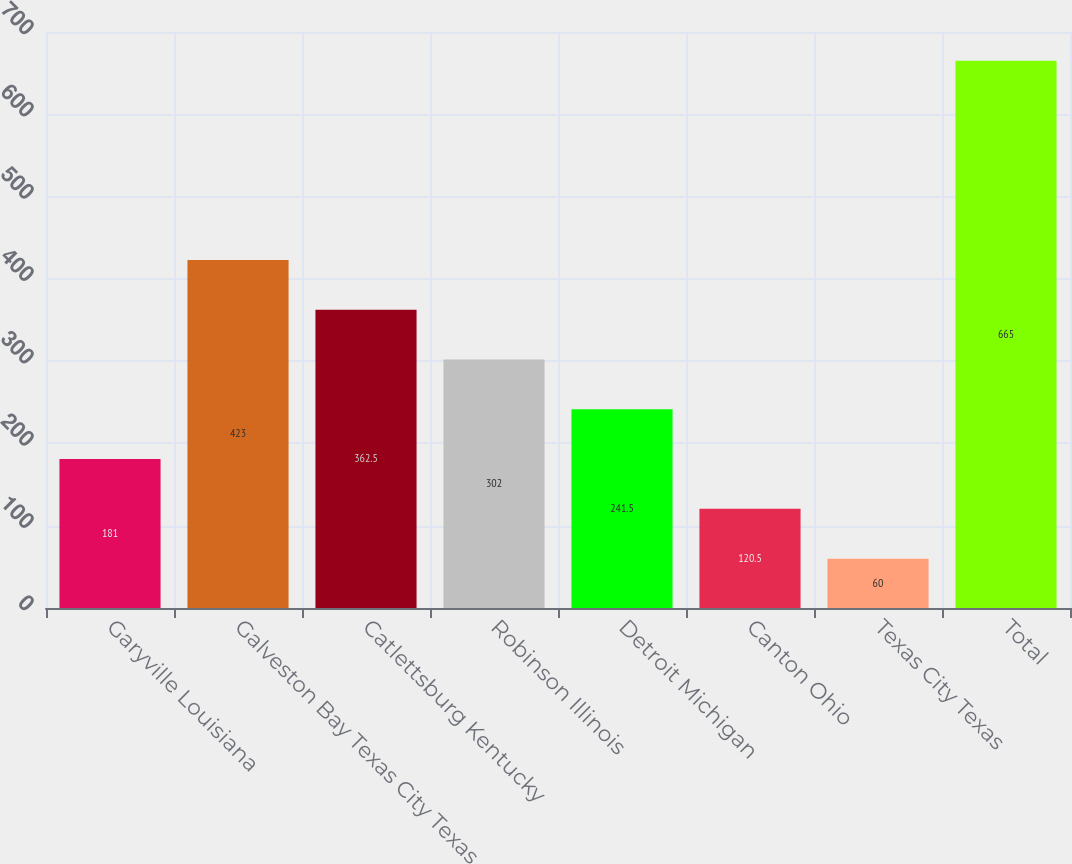Convert chart. <chart><loc_0><loc_0><loc_500><loc_500><bar_chart><fcel>Garyville Louisiana<fcel>Galveston Bay Texas City Texas<fcel>Catlettsburg Kentucky<fcel>Robinson Illinois<fcel>Detroit Michigan<fcel>Canton Ohio<fcel>Texas City Texas<fcel>Total<nl><fcel>181<fcel>423<fcel>362.5<fcel>302<fcel>241.5<fcel>120.5<fcel>60<fcel>665<nl></chart> 